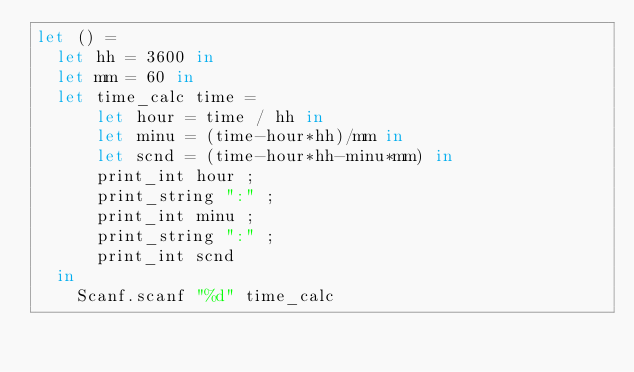<code> <loc_0><loc_0><loc_500><loc_500><_OCaml_>let () =
  let hh = 3600 in
  let mm = 60 in
  let time_calc time =
      let hour = time / hh in
      let minu = (time-hour*hh)/mm in
      let scnd = (time-hour*hh-minu*mm) in
      print_int hour ;
      print_string ":" ;
      print_int minu ;
      print_string ":" ;
      print_int scnd
  in
    Scanf.scanf "%d" time_calc</code> 